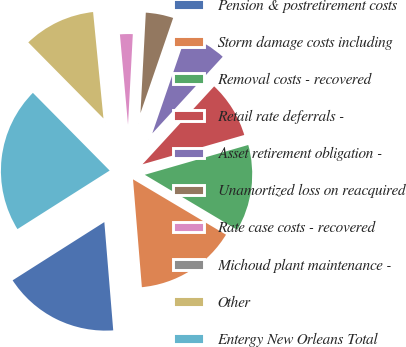Convert chart to OTSL. <chart><loc_0><loc_0><loc_500><loc_500><pie_chart><fcel>Pension & postretirement costs<fcel>Storm damage costs including<fcel>Removal costs - recovered<fcel>Retail rate deferrals -<fcel>Asset retirement obligation -<fcel>Unamortized loss on reacquired<fcel>Rate case costs - recovered<fcel>Michoud plant maintenance -<fcel>Other<fcel>Entergy New Orleans Total<nl><fcel>17.3%<fcel>15.15%<fcel>13.01%<fcel>8.71%<fcel>6.56%<fcel>4.42%<fcel>2.27%<fcel>0.12%<fcel>10.86%<fcel>21.6%<nl></chart> 